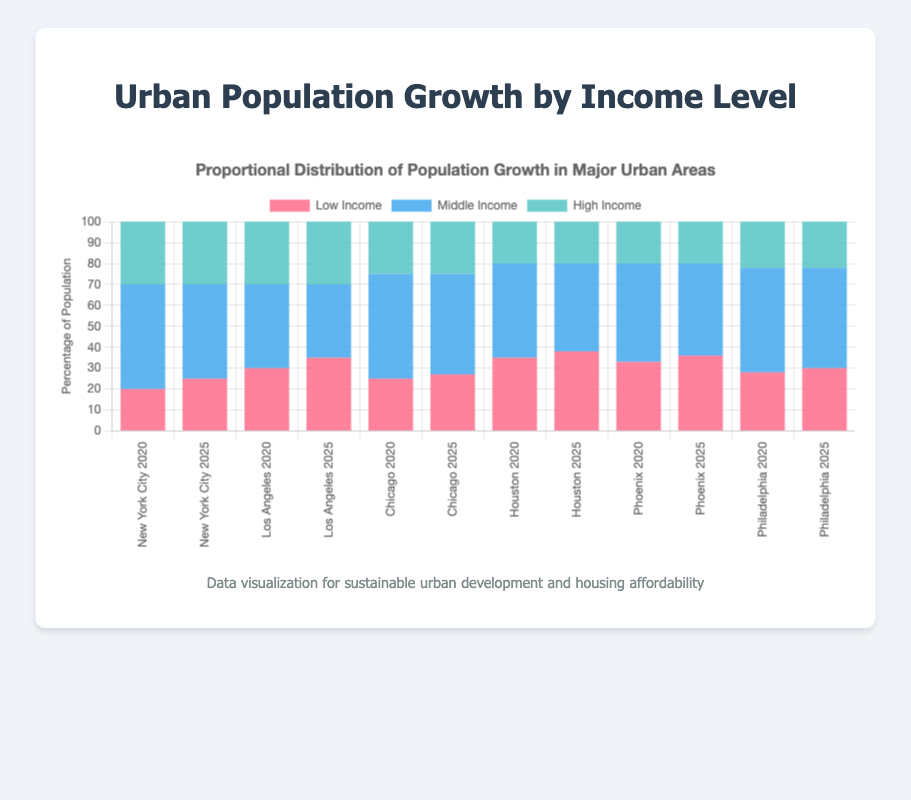Which cities show an increase in the proportion of low-income populations from 2020 to 2025? To determine this, check the low-income population percentages for 2020 and 2025 in each city. New York City (20% to 25%), Los Angeles (30% to 35%), Chicago (25% to 27%), Houston (35% to 38%), Phoenix (33% to 36%), and Philadelphia (28% to 30%) all show increases.
Answer: New York City, Los Angeles, Chicago, Houston, Phoenix, Philadelphia Which city had the highest proportion of low-income population in 2020? Look at the height of the red bar (representing low-income) for each city in 2020. Houston (35%) has the highest red bar.
Answer: Houston Compare the proportions of middle-income populations in New York City and Los Angeles in 2025. Which city has a higher percentage? Observing the blue bars (representing middle-income) in 2025 for both cities, New York City has 45%, and Los Angeles has 35%. New York City has a higher percentage.
Answer: New York City By how much did the proportion of middle-income population in Chicago decrease from 2020 to 2025? In 2020, Chicago’s middle-income population is 50%. In 2025, it is 48%. The decrease is 50% - 48% = 2%.
Answer: 2% In 2025, what is the combined proportion of low-income and middle-income populations in Phoenix? Add the proportions of low-income (36%) and middle-income (44%) populations in Phoenix for 2025: 36% + 44% = 80%.
Answer: 80% Which city exhibits no change in the proportion of high-income population between 2020 and 2025? Look at the green bars representing high-income populations for each city. New York City (30%), Los Angeles (30%), Chicago (25%), Houston (20%), Phoenix (20%), and Philadelphia (22%) all show no change.
Answer: New York City, Los Angeles, Chicago, Houston, Phoenix, Philadelphia What is the average proportion of high-income population across all cities in 2025? Sum the high-income proportions for all cities in 2025: (New York City: 30% + Los Angeles: 30% + Chicago: 25% + Houston: 20% + Phoenix: 20% + Philadelphia: 22%) = 147%. There are 6 cities, so the average is 147% / 6 = 24.5%.
Answer: 24.5% Visually, which income level has the most balanced distribution across all cities in 2025, and why? Observe the heights of bars for each income level in 2025. The high-income bars (green) are relatively similar in height across all cities (ranging from 20% to 30%), indicating the most balanced distribution.
Answer: High-income, because the proportions are close to each other 